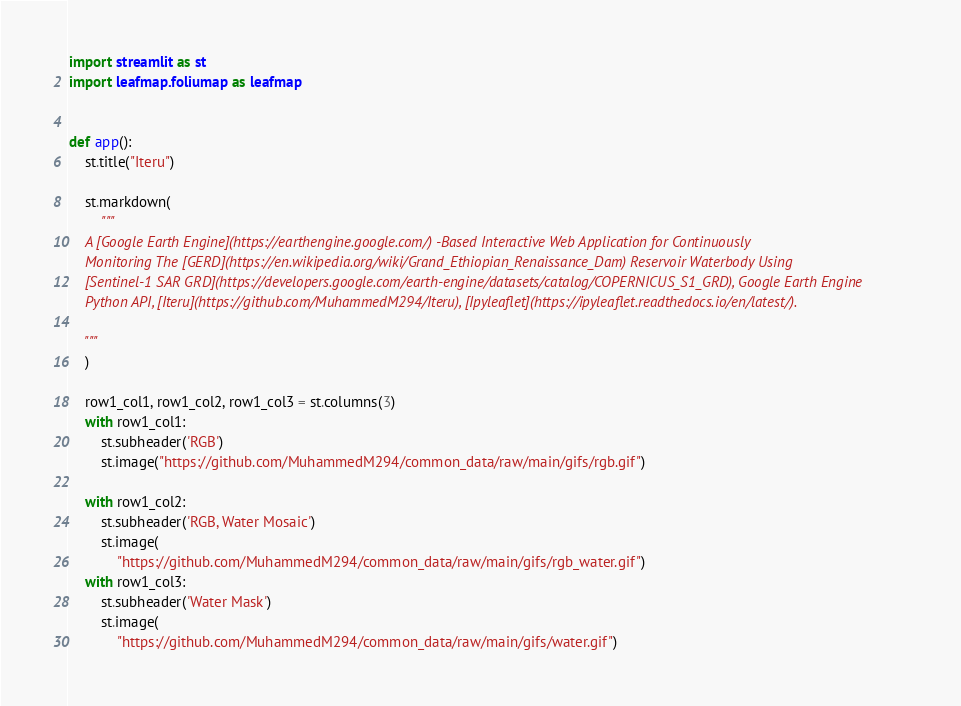<code> <loc_0><loc_0><loc_500><loc_500><_Python_>import streamlit as st
import leafmap.foliumap as leafmap


def app():
    st.title("Iteru")

    st.markdown(
        """
    A [Google Earth Engine](https://earthengine.google.com/) -Based Interactive Web Application for Continuously
    Monitoring The [GERD](https://en.wikipedia.org/wiki/Grand_Ethiopian_Renaissance_Dam) Reservoir Waterbody Using 
    [Sentinel-1 SAR GRD](https://developers.google.com/earth-engine/datasets/catalog/COPERNICUS_S1_GRD), Google Earth Engine
    Python API, [Iteru](https://github.com/MuhammedM294/Iteru), [Ipyleaflet](https://ipyleaflet.readthedocs.io/en/latest/).
    
    """
    )

    row1_col1, row1_col2, row1_col3 = st.columns(3)
    with row1_col1:
        st.subheader('RGB')
        st.image("https://github.com/MuhammedM294/common_data/raw/main/gifs/rgb.gif")

    with row1_col2:
        st.subheader('RGB, Water Mosaic')
        st.image(
            "https://github.com/MuhammedM294/common_data/raw/main/gifs/rgb_water.gif")
    with row1_col3:
        st.subheader('Water Mask')
        st.image(
            "https://github.com/MuhammedM294/common_data/raw/main/gifs/water.gif")
</code> 